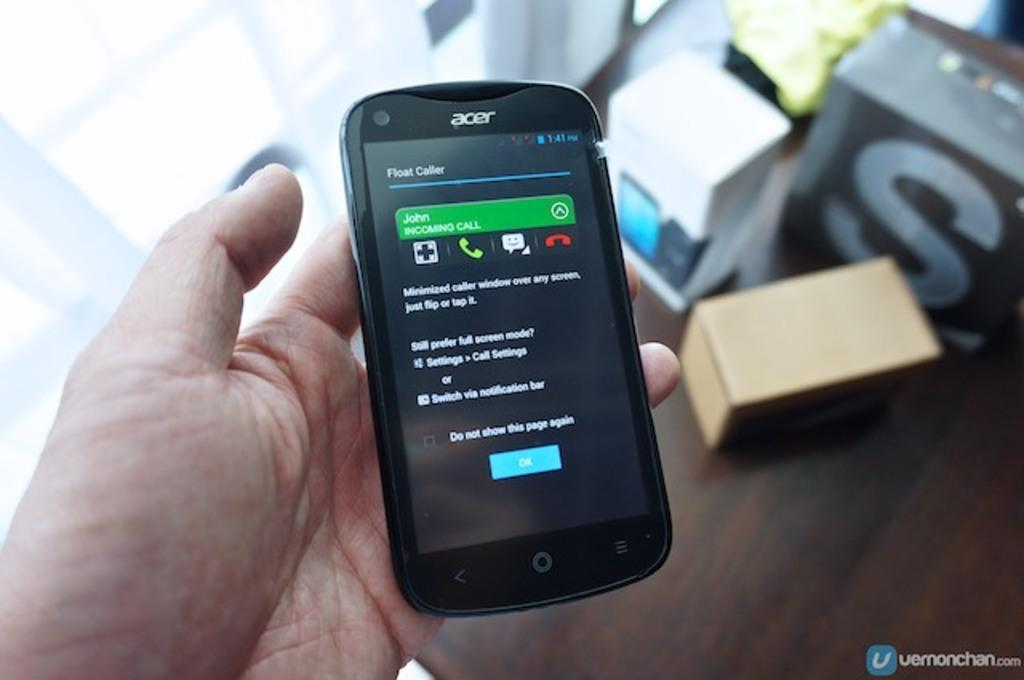<image>
Share a concise interpretation of the image provided. The black acer phone rests in the persons hand 